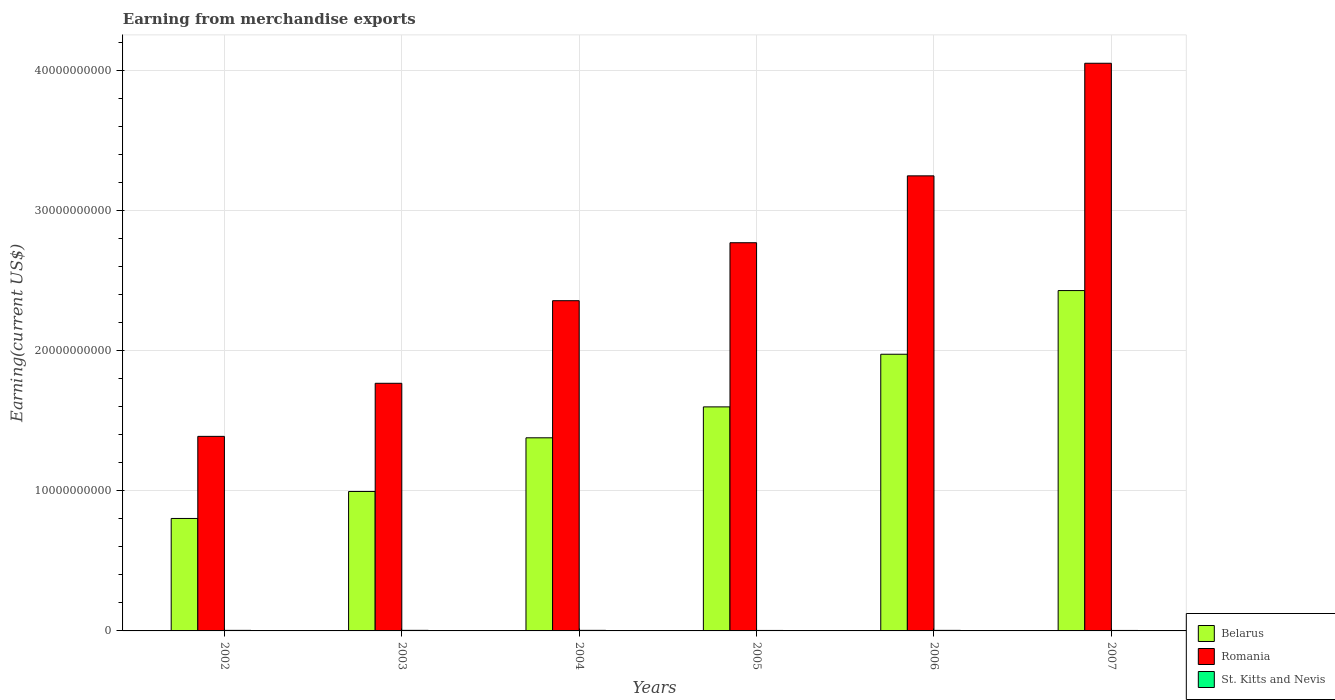How many different coloured bars are there?
Your response must be concise. 3. Are the number of bars per tick equal to the number of legend labels?
Make the answer very short. Yes. What is the amount earned from merchandise exports in Belarus in 2004?
Provide a short and direct response. 1.38e+1. Across all years, what is the maximum amount earned from merchandise exports in Romania?
Your answer should be compact. 4.05e+1. Across all years, what is the minimum amount earned from merchandise exports in Romania?
Your answer should be compact. 1.39e+1. What is the total amount earned from merchandise exports in Belarus in the graph?
Your answer should be compact. 9.17e+1. What is the difference between the amount earned from merchandise exports in St. Kitts and Nevis in 2003 and that in 2005?
Make the answer very short. 6.69e+06. What is the difference between the amount earned from merchandise exports in St. Kitts and Nevis in 2005 and the amount earned from merchandise exports in Belarus in 2003?
Your answer should be very brief. -9.91e+09. What is the average amount earned from merchandise exports in Belarus per year?
Provide a short and direct response. 1.53e+1. In the year 2005, what is the difference between the amount earned from merchandise exports in Belarus and amount earned from merchandise exports in St. Kitts and Nevis?
Offer a very short reply. 1.59e+1. What is the ratio of the amount earned from merchandise exports in Romania in 2004 to that in 2006?
Make the answer very short. 0.73. Is the amount earned from merchandise exports in Romania in 2004 less than that in 2006?
Your answer should be compact. Yes. What is the difference between the highest and the second highest amount earned from merchandise exports in Belarus?
Your answer should be very brief. 4.54e+09. What is the difference between the highest and the lowest amount earned from merchandise exports in St. Kitts and Nevis?
Provide a succinct answer. 6.69e+06. What does the 1st bar from the left in 2006 represents?
Ensure brevity in your answer.  Belarus. What does the 2nd bar from the right in 2004 represents?
Your answer should be very brief. Romania. Is it the case that in every year, the sum of the amount earned from merchandise exports in St. Kitts and Nevis and amount earned from merchandise exports in Romania is greater than the amount earned from merchandise exports in Belarus?
Make the answer very short. Yes. How many bars are there?
Ensure brevity in your answer.  18. How many years are there in the graph?
Make the answer very short. 6. Does the graph contain any zero values?
Make the answer very short. No. What is the title of the graph?
Provide a short and direct response. Earning from merchandise exports. Does "Mauritania" appear as one of the legend labels in the graph?
Give a very brief answer. No. What is the label or title of the X-axis?
Make the answer very short. Years. What is the label or title of the Y-axis?
Keep it short and to the point. Earning(current US$). What is the Earning(current US$) in Belarus in 2002?
Make the answer very short. 8.02e+09. What is the Earning(current US$) of Romania in 2002?
Offer a very short reply. 1.39e+1. What is the Earning(current US$) of St. Kitts and Nevis in 2002?
Provide a succinct answer. 3.90e+07. What is the Earning(current US$) of Belarus in 2003?
Make the answer very short. 9.95e+09. What is the Earning(current US$) of Romania in 2003?
Your answer should be very brief. 1.77e+1. What is the Earning(current US$) in St. Kitts and Nevis in 2003?
Give a very brief answer. 4.10e+07. What is the Earning(current US$) of Belarus in 2004?
Ensure brevity in your answer.  1.38e+1. What is the Earning(current US$) in Romania in 2004?
Give a very brief answer. 2.36e+1. What is the Earning(current US$) in St. Kitts and Nevis in 2004?
Give a very brief answer. 4.02e+07. What is the Earning(current US$) in Belarus in 2005?
Your response must be concise. 1.60e+1. What is the Earning(current US$) of Romania in 2005?
Ensure brevity in your answer.  2.77e+1. What is the Earning(current US$) in St. Kitts and Nevis in 2005?
Ensure brevity in your answer.  3.43e+07. What is the Earning(current US$) of Belarus in 2006?
Your answer should be compact. 1.97e+1. What is the Earning(current US$) in Romania in 2006?
Ensure brevity in your answer.  3.25e+1. What is the Earning(current US$) of St. Kitts and Nevis in 2006?
Your response must be concise. 3.97e+07. What is the Earning(current US$) in Belarus in 2007?
Offer a terse response. 2.43e+1. What is the Earning(current US$) of Romania in 2007?
Provide a succinct answer. 4.05e+1. What is the Earning(current US$) of St. Kitts and Nevis in 2007?
Give a very brief answer. 3.44e+07. Across all years, what is the maximum Earning(current US$) in Belarus?
Offer a very short reply. 2.43e+1. Across all years, what is the maximum Earning(current US$) of Romania?
Keep it short and to the point. 4.05e+1. Across all years, what is the maximum Earning(current US$) in St. Kitts and Nevis?
Ensure brevity in your answer.  4.10e+07. Across all years, what is the minimum Earning(current US$) in Belarus?
Keep it short and to the point. 8.02e+09. Across all years, what is the minimum Earning(current US$) in Romania?
Give a very brief answer. 1.39e+1. Across all years, what is the minimum Earning(current US$) of St. Kitts and Nevis?
Offer a very short reply. 3.43e+07. What is the total Earning(current US$) in Belarus in the graph?
Your answer should be compact. 9.17e+1. What is the total Earning(current US$) in Romania in the graph?
Your answer should be compact. 1.56e+11. What is the total Earning(current US$) in St. Kitts and Nevis in the graph?
Give a very brief answer. 2.29e+08. What is the difference between the Earning(current US$) of Belarus in 2002 and that in 2003?
Give a very brief answer. -1.92e+09. What is the difference between the Earning(current US$) in Romania in 2002 and that in 2003?
Make the answer very short. -3.79e+09. What is the difference between the Earning(current US$) of Belarus in 2002 and that in 2004?
Your answer should be compact. -5.75e+09. What is the difference between the Earning(current US$) of Romania in 2002 and that in 2004?
Provide a succinct answer. -9.68e+09. What is the difference between the Earning(current US$) of St. Kitts and Nevis in 2002 and that in 2004?
Offer a terse response. -1.25e+06. What is the difference between the Earning(current US$) of Belarus in 2002 and that in 2005?
Your response must be concise. -7.96e+09. What is the difference between the Earning(current US$) of Romania in 2002 and that in 2005?
Your answer should be very brief. -1.38e+1. What is the difference between the Earning(current US$) of St. Kitts and Nevis in 2002 and that in 2005?
Keep it short and to the point. 4.69e+06. What is the difference between the Earning(current US$) of Belarus in 2002 and that in 2006?
Your answer should be compact. -1.17e+1. What is the difference between the Earning(current US$) of Romania in 2002 and that in 2006?
Provide a succinct answer. -1.86e+1. What is the difference between the Earning(current US$) of St. Kitts and Nevis in 2002 and that in 2006?
Keep it short and to the point. -7.06e+05. What is the difference between the Earning(current US$) of Belarus in 2002 and that in 2007?
Your response must be concise. -1.63e+1. What is the difference between the Earning(current US$) in Romania in 2002 and that in 2007?
Provide a short and direct response. -2.66e+1. What is the difference between the Earning(current US$) of St. Kitts and Nevis in 2002 and that in 2007?
Provide a short and direct response. 4.62e+06. What is the difference between the Earning(current US$) in Belarus in 2003 and that in 2004?
Ensure brevity in your answer.  -3.83e+09. What is the difference between the Earning(current US$) of Romania in 2003 and that in 2004?
Offer a very short reply. -5.89e+09. What is the difference between the Earning(current US$) in St. Kitts and Nevis in 2003 and that in 2004?
Make the answer very short. 7.53e+05. What is the difference between the Earning(current US$) in Belarus in 2003 and that in 2005?
Your response must be concise. -6.03e+09. What is the difference between the Earning(current US$) in Romania in 2003 and that in 2005?
Make the answer very short. -1.00e+1. What is the difference between the Earning(current US$) in St. Kitts and Nevis in 2003 and that in 2005?
Make the answer very short. 6.69e+06. What is the difference between the Earning(current US$) in Belarus in 2003 and that in 2006?
Provide a short and direct response. -9.79e+09. What is the difference between the Earning(current US$) of Romania in 2003 and that in 2006?
Your answer should be very brief. -1.48e+1. What is the difference between the Earning(current US$) of St. Kitts and Nevis in 2003 and that in 2006?
Provide a short and direct response. 1.29e+06. What is the difference between the Earning(current US$) in Belarus in 2003 and that in 2007?
Your answer should be compact. -1.43e+1. What is the difference between the Earning(current US$) in Romania in 2003 and that in 2007?
Ensure brevity in your answer.  -2.28e+1. What is the difference between the Earning(current US$) in St. Kitts and Nevis in 2003 and that in 2007?
Offer a very short reply. 6.62e+06. What is the difference between the Earning(current US$) in Belarus in 2004 and that in 2005?
Keep it short and to the point. -2.21e+09. What is the difference between the Earning(current US$) in Romania in 2004 and that in 2005?
Your response must be concise. -4.13e+09. What is the difference between the Earning(current US$) of St. Kitts and Nevis in 2004 and that in 2005?
Keep it short and to the point. 5.94e+06. What is the difference between the Earning(current US$) of Belarus in 2004 and that in 2006?
Your answer should be very brief. -5.96e+09. What is the difference between the Earning(current US$) in Romania in 2004 and that in 2006?
Provide a short and direct response. -8.90e+09. What is the difference between the Earning(current US$) of St. Kitts and Nevis in 2004 and that in 2006?
Keep it short and to the point. 5.41e+05. What is the difference between the Earning(current US$) in Belarus in 2004 and that in 2007?
Provide a succinct answer. -1.05e+1. What is the difference between the Earning(current US$) in Romania in 2004 and that in 2007?
Your answer should be compact. -1.69e+1. What is the difference between the Earning(current US$) in St. Kitts and Nevis in 2004 and that in 2007?
Provide a short and direct response. 5.87e+06. What is the difference between the Earning(current US$) of Belarus in 2005 and that in 2006?
Your response must be concise. -3.76e+09. What is the difference between the Earning(current US$) of Romania in 2005 and that in 2006?
Keep it short and to the point. -4.77e+09. What is the difference between the Earning(current US$) in St. Kitts and Nevis in 2005 and that in 2006?
Your response must be concise. -5.40e+06. What is the difference between the Earning(current US$) of Belarus in 2005 and that in 2007?
Provide a short and direct response. -8.30e+09. What is the difference between the Earning(current US$) in Romania in 2005 and that in 2007?
Keep it short and to the point. -1.28e+1. What is the difference between the Earning(current US$) in St. Kitts and Nevis in 2005 and that in 2007?
Your response must be concise. -7.32e+04. What is the difference between the Earning(current US$) in Belarus in 2006 and that in 2007?
Offer a terse response. -4.54e+09. What is the difference between the Earning(current US$) of Romania in 2006 and that in 2007?
Give a very brief answer. -8.03e+09. What is the difference between the Earning(current US$) of St. Kitts and Nevis in 2006 and that in 2007?
Provide a short and direct response. 5.33e+06. What is the difference between the Earning(current US$) of Belarus in 2002 and the Earning(current US$) of Romania in 2003?
Your answer should be very brief. -9.64e+09. What is the difference between the Earning(current US$) in Belarus in 2002 and the Earning(current US$) in St. Kitts and Nevis in 2003?
Offer a terse response. 7.98e+09. What is the difference between the Earning(current US$) of Romania in 2002 and the Earning(current US$) of St. Kitts and Nevis in 2003?
Keep it short and to the point. 1.38e+1. What is the difference between the Earning(current US$) in Belarus in 2002 and the Earning(current US$) in Romania in 2004?
Your answer should be very brief. -1.55e+1. What is the difference between the Earning(current US$) in Belarus in 2002 and the Earning(current US$) in St. Kitts and Nevis in 2004?
Your response must be concise. 7.98e+09. What is the difference between the Earning(current US$) in Romania in 2002 and the Earning(current US$) in St. Kitts and Nevis in 2004?
Your response must be concise. 1.38e+1. What is the difference between the Earning(current US$) of Belarus in 2002 and the Earning(current US$) of Romania in 2005?
Make the answer very short. -1.97e+1. What is the difference between the Earning(current US$) of Belarus in 2002 and the Earning(current US$) of St. Kitts and Nevis in 2005?
Ensure brevity in your answer.  7.99e+09. What is the difference between the Earning(current US$) of Romania in 2002 and the Earning(current US$) of St. Kitts and Nevis in 2005?
Make the answer very short. 1.38e+1. What is the difference between the Earning(current US$) of Belarus in 2002 and the Earning(current US$) of Romania in 2006?
Provide a short and direct response. -2.44e+1. What is the difference between the Earning(current US$) of Belarus in 2002 and the Earning(current US$) of St. Kitts and Nevis in 2006?
Offer a very short reply. 7.98e+09. What is the difference between the Earning(current US$) in Romania in 2002 and the Earning(current US$) in St. Kitts and Nevis in 2006?
Keep it short and to the point. 1.38e+1. What is the difference between the Earning(current US$) of Belarus in 2002 and the Earning(current US$) of Romania in 2007?
Offer a very short reply. -3.25e+1. What is the difference between the Earning(current US$) in Belarus in 2002 and the Earning(current US$) in St. Kitts and Nevis in 2007?
Give a very brief answer. 7.99e+09. What is the difference between the Earning(current US$) of Romania in 2002 and the Earning(current US$) of St. Kitts and Nevis in 2007?
Keep it short and to the point. 1.38e+1. What is the difference between the Earning(current US$) of Belarus in 2003 and the Earning(current US$) of Romania in 2004?
Provide a short and direct response. -1.36e+1. What is the difference between the Earning(current US$) of Belarus in 2003 and the Earning(current US$) of St. Kitts and Nevis in 2004?
Make the answer very short. 9.91e+09. What is the difference between the Earning(current US$) of Romania in 2003 and the Earning(current US$) of St. Kitts and Nevis in 2004?
Your answer should be compact. 1.76e+1. What is the difference between the Earning(current US$) of Belarus in 2003 and the Earning(current US$) of Romania in 2005?
Make the answer very short. -1.77e+1. What is the difference between the Earning(current US$) in Belarus in 2003 and the Earning(current US$) in St. Kitts and Nevis in 2005?
Keep it short and to the point. 9.91e+09. What is the difference between the Earning(current US$) in Romania in 2003 and the Earning(current US$) in St. Kitts and Nevis in 2005?
Offer a terse response. 1.76e+1. What is the difference between the Earning(current US$) in Belarus in 2003 and the Earning(current US$) in Romania in 2006?
Make the answer very short. -2.25e+1. What is the difference between the Earning(current US$) of Belarus in 2003 and the Earning(current US$) of St. Kitts and Nevis in 2006?
Your response must be concise. 9.91e+09. What is the difference between the Earning(current US$) in Romania in 2003 and the Earning(current US$) in St. Kitts and Nevis in 2006?
Your answer should be very brief. 1.76e+1. What is the difference between the Earning(current US$) of Belarus in 2003 and the Earning(current US$) of Romania in 2007?
Your response must be concise. -3.05e+1. What is the difference between the Earning(current US$) of Belarus in 2003 and the Earning(current US$) of St. Kitts and Nevis in 2007?
Your answer should be very brief. 9.91e+09. What is the difference between the Earning(current US$) of Romania in 2003 and the Earning(current US$) of St. Kitts and Nevis in 2007?
Offer a terse response. 1.76e+1. What is the difference between the Earning(current US$) in Belarus in 2004 and the Earning(current US$) in Romania in 2005?
Keep it short and to the point. -1.39e+1. What is the difference between the Earning(current US$) of Belarus in 2004 and the Earning(current US$) of St. Kitts and Nevis in 2005?
Provide a short and direct response. 1.37e+1. What is the difference between the Earning(current US$) in Romania in 2004 and the Earning(current US$) in St. Kitts and Nevis in 2005?
Your answer should be compact. 2.35e+1. What is the difference between the Earning(current US$) in Belarus in 2004 and the Earning(current US$) in Romania in 2006?
Your answer should be compact. -1.87e+1. What is the difference between the Earning(current US$) in Belarus in 2004 and the Earning(current US$) in St. Kitts and Nevis in 2006?
Provide a short and direct response. 1.37e+1. What is the difference between the Earning(current US$) of Romania in 2004 and the Earning(current US$) of St. Kitts and Nevis in 2006?
Provide a succinct answer. 2.35e+1. What is the difference between the Earning(current US$) of Belarus in 2004 and the Earning(current US$) of Romania in 2007?
Give a very brief answer. -2.67e+1. What is the difference between the Earning(current US$) in Belarus in 2004 and the Earning(current US$) in St. Kitts and Nevis in 2007?
Give a very brief answer. 1.37e+1. What is the difference between the Earning(current US$) of Romania in 2004 and the Earning(current US$) of St. Kitts and Nevis in 2007?
Your response must be concise. 2.35e+1. What is the difference between the Earning(current US$) in Belarus in 2005 and the Earning(current US$) in Romania in 2006?
Provide a succinct answer. -1.65e+1. What is the difference between the Earning(current US$) of Belarus in 2005 and the Earning(current US$) of St. Kitts and Nevis in 2006?
Your answer should be compact. 1.59e+1. What is the difference between the Earning(current US$) of Romania in 2005 and the Earning(current US$) of St. Kitts and Nevis in 2006?
Your answer should be very brief. 2.76e+1. What is the difference between the Earning(current US$) in Belarus in 2005 and the Earning(current US$) in Romania in 2007?
Provide a short and direct response. -2.45e+1. What is the difference between the Earning(current US$) of Belarus in 2005 and the Earning(current US$) of St. Kitts and Nevis in 2007?
Your answer should be compact. 1.59e+1. What is the difference between the Earning(current US$) in Romania in 2005 and the Earning(current US$) in St. Kitts and Nevis in 2007?
Your response must be concise. 2.77e+1. What is the difference between the Earning(current US$) of Belarus in 2006 and the Earning(current US$) of Romania in 2007?
Make the answer very short. -2.08e+1. What is the difference between the Earning(current US$) in Belarus in 2006 and the Earning(current US$) in St. Kitts and Nevis in 2007?
Your answer should be very brief. 1.97e+1. What is the difference between the Earning(current US$) of Romania in 2006 and the Earning(current US$) of St. Kitts and Nevis in 2007?
Your answer should be compact. 3.24e+1. What is the average Earning(current US$) of Belarus per year?
Provide a short and direct response. 1.53e+1. What is the average Earning(current US$) in Romania per year?
Give a very brief answer. 2.60e+1. What is the average Earning(current US$) of St. Kitts and Nevis per year?
Your response must be concise. 3.81e+07. In the year 2002, what is the difference between the Earning(current US$) in Belarus and Earning(current US$) in Romania?
Provide a short and direct response. -5.86e+09. In the year 2002, what is the difference between the Earning(current US$) in Belarus and Earning(current US$) in St. Kitts and Nevis?
Offer a very short reply. 7.98e+09. In the year 2002, what is the difference between the Earning(current US$) in Romania and Earning(current US$) in St. Kitts and Nevis?
Give a very brief answer. 1.38e+1. In the year 2003, what is the difference between the Earning(current US$) of Belarus and Earning(current US$) of Romania?
Make the answer very short. -7.72e+09. In the year 2003, what is the difference between the Earning(current US$) of Belarus and Earning(current US$) of St. Kitts and Nevis?
Offer a terse response. 9.90e+09. In the year 2003, what is the difference between the Earning(current US$) in Romania and Earning(current US$) in St. Kitts and Nevis?
Give a very brief answer. 1.76e+1. In the year 2004, what is the difference between the Earning(current US$) in Belarus and Earning(current US$) in Romania?
Your answer should be very brief. -9.78e+09. In the year 2004, what is the difference between the Earning(current US$) of Belarus and Earning(current US$) of St. Kitts and Nevis?
Keep it short and to the point. 1.37e+1. In the year 2004, what is the difference between the Earning(current US$) of Romania and Earning(current US$) of St. Kitts and Nevis?
Your answer should be very brief. 2.35e+1. In the year 2005, what is the difference between the Earning(current US$) of Belarus and Earning(current US$) of Romania?
Ensure brevity in your answer.  -1.17e+1. In the year 2005, what is the difference between the Earning(current US$) of Belarus and Earning(current US$) of St. Kitts and Nevis?
Your answer should be very brief. 1.59e+1. In the year 2005, what is the difference between the Earning(current US$) of Romania and Earning(current US$) of St. Kitts and Nevis?
Provide a succinct answer. 2.77e+1. In the year 2006, what is the difference between the Earning(current US$) in Belarus and Earning(current US$) in Romania?
Offer a very short reply. -1.27e+1. In the year 2006, what is the difference between the Earning(current US$) in Belarus and Earning(current US$) in St. Kitts and Nevis?
Provide a succinct answer. 1.97e+1. In the year 2006, what is the difference between the Earning(current US$) of Romania and Earning(current US$) of St. Kitts and Nevis?
Your answer should be very brief. 3.24e+1. In the year 2007, what is the difference between the Earning(current US$) of Belarus and Earning(current US$) of Romania?
Your response must be concise. -1.62e+1. In the year 2007, what is the difference between the Earning(current US$) of Belarus and Earning(current US$) of St. Kitts and Nevis?
Provide a short and direct response. 2.42e+1. In the year 2007, what is the difference between the Earning(current US$) of Romania and Earning(current US$) of St. Kitts and Nevis?
Offer a very short reply. 4.05e+1. What is the ratio of the Earning(current US$) of Belarus in 2002 to that in 2003?
Provide a succinct answer. 0.81. What is the ratio of the Earning(current US$) of Romania in 2002 to that in 2003?
Ensure brevity in your answer.  0.79. What is the ratio of the Earning(current US$) of St. Kitts and Nevis in 2002 to that in 2003?
Provide a succinct answer. 0.95. What is the ratio of the Earning(current US$) in Belarus in 2002 to that in 2004?
Provide a short and direct response. 0.58. What is the ratio of the Earning(current US$) of Romania in 2002 to that in 2004?
Provide a short and direct response. 0.59. What is the ratio of the Earning(current US$) in Belarus in 2002 to that in 2005?
Provide a succinct answer. 0.5. What is the ratio of the Earning(current US$) in Romania in 2002 to that in 2005?
Make the answer very short. 0.5. What is the ratio of the Earning(current US$) in St. Kitts and Nevis in 2002 to that in 2005?
Offer a very short reply. 1.14. What is the ratio of the Earning(current US$) of Belarus in 2002 to that in 2006?
Make the answer very short. 0.41. What is the ratio of the Earning(current US$) of Romania in 2002 to that in 2006?
Your answer should be very brief. 0.43. What is the ratio of the Earning(current US$) in St. Kitts and Nevis in 2002 to that in 2006?
Your answer should be compact. 0.98. What is the ratio of the Earning(current US$) in Belarus in 2002 to that in 2007?
Your answer should be very brief. 0.33. What is the ratio of the Earning(current US$) in Romania in 2002 to that in 2007?
Keep it short and to the point. 0.34. What is the ratio of the Earning(current US$) in St. Kitts and Nevis in 2002 to that in 2007?
Give a very brief answer. 1.13. What is the ratio of the Earning(current US$) of Belarus in 2003 to that in 2004?
Offer a terse response. 0.72. What is the ratio of the Earning(current US$) of Romania in 2003 to that in 2004?
Offer a very short reply. 0.75. What is the ratio of the Earning(current US$) in St. Kitts and Nevis in 2003 to that in 2004?
Your response must be concise. 1.02. What is the ratio of the Earning(current US$) in Belarus in 2003 to that in 2005?
Give a very brief answer. 0.62. What is the ratio of the Earning(current US$) in Romania in 2003 to that in 2005?
Give a very brief answer. 0.64. What is the ratio of the Earning(current US$) in St. Kitts and Nevis in 2003 to that in 2005?
Make the answer very short. 1.2. What is the ratio of the Earning(current US$) of Belarus in 2003 to that in 2006?
Provide a short and direct response. 0.5. What is the ratio of the Earning(current US$) in Romania in 2003 to that in 2006?
Provide a short and direct response. 0.54. What is the ratio of the Earning(current US$) in St. Kitts and Nevis in 2003 to that in 2006?
Give a very brief answer. 1.03. What is the ratio of the Earning(current US$) in Belarus in 2003 to that in 2007?
Provide a succinct answer. 0.41. What is the ratio of the Earning(current US$) in Romania in 2003 to that in 2007?
Your answer should be very brief. 0.44. What is the ratio of the Earning(current US$) of St. Kitts and Nevis in 2003 to that in 2007?
Make the answer very short. 1.19. What is the ratio of the Earning(current US$) of Belarus in 2004 to that in 2005?
Offer a very short reply. 0.86. What is the ratio of the Earning(current US$) of Romania in 2004 to that in 2005?
Your answer should be very brief. 0.85. What is the ratio of the Earning(current US$) in St. Kitts and Nevis in 2004 to that in 2005?
Your response must be concise. 1.17. What is the ratio of the Earning(current US$) in Belarus in 2004 to that in 2006?
Ensure brevity in your answer.  0.7. What is the ratio of the Earning(current US$) of Romania in 2004 to that in 2006?
Your answer should be very brief. 0.73. What is the ratio of the Earning(current US$) in St. Kitts and Nevis in 2004 to that in 2006?
Provide a succinct answer. 1.01. What is the ratio of the Earning(current US$) of Belarus in 2004 to that in 2007?
Offer a terse response. 0.57. What is the ratio of the Earning(current US$) of Romania in 2004 to that in 2007?
Provide a short and direct response. 0.58. What is the ratio of the Earning(current US$) in St. Kitts and Nevis in 2004 to that in 2007?
Ensure brevity in your answer.  1.17. What is the ratio of the Earning(current US$) in Belarus in 2005 to that in 2006?
Provide a succinct answer. 0.81. What is the ratio of the Earning(current US$) in Romania in 2005 to that in 2006?
Offer a very short reply. 0.85. What is the ratio of the Earning(current US$) in St. Kitts and Nevis in 2005 to that in 2006?
Keep it short and to the point. 0.86. What is the ratio of the Earning(current US$) in Belarus in 2005 to that in 2007?
Your answer should be compact. 0.66. What is the ratio of the Earning(current US$) in Romania in 2005 to that in 2007?
Provide a short and direct response. 0.68. What is the ratio of the Earning(current US$) in St. Kitts and Nevis in 2005 to that in 2007?
Give a very brief answer. 1. What is the ratio of the Earning(current US$) in Belarus in 2006 to that in 2007?
Give a very brief answer. 0.81. What is the ratio of the Earning(current US$) in Romania in 2006 to that in 2007?
Provide a short and direct response. 0.8. What is the ratio of the Earning(current US$) in St. Kitts and Nevis in 2006 to that in 2007?
Your response must be concise. 1.15. What is the difference between the highest and the second highest Earning(current US$) in Belarus?
Provide a succinct answer. 4.54e+09. What is the difference between the highest and the second highest Earning(current US$) in Romania?
Your answer should be very brief. 8.03e+09. What is the difference between the highest and the second highest Earning(current US$) of St. Kitts and Nevis?
Your answer should be very brief. 7.53e+05. What is the difference between the highest and the lowest Earning(current US$) in Belarus?
Make the answer very short. 1.63e+1. What is the difference between the highest and the lowest Earning(current US$) of Romania?
Offer a terse response. 2.66e+1. What is the difference between the highest and the lowest Earning(current US$) of St. Kitts and Nevis?
Keep it short and to the point. 6.69e+06. 